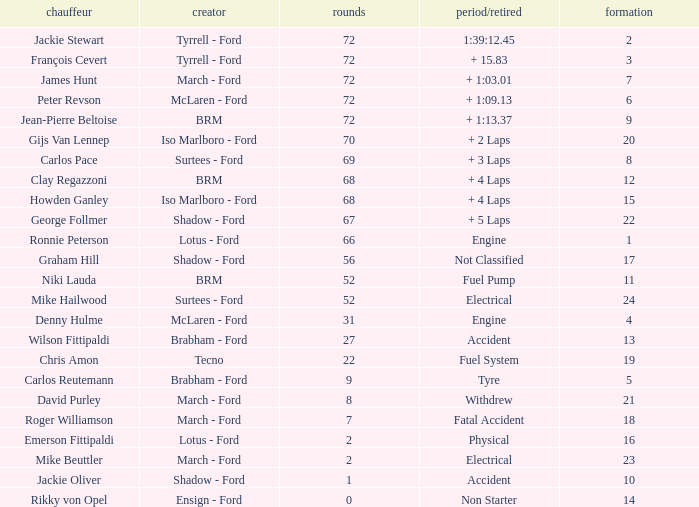What is the top grid that laps less than 66 and a retried engine? 4.0. 